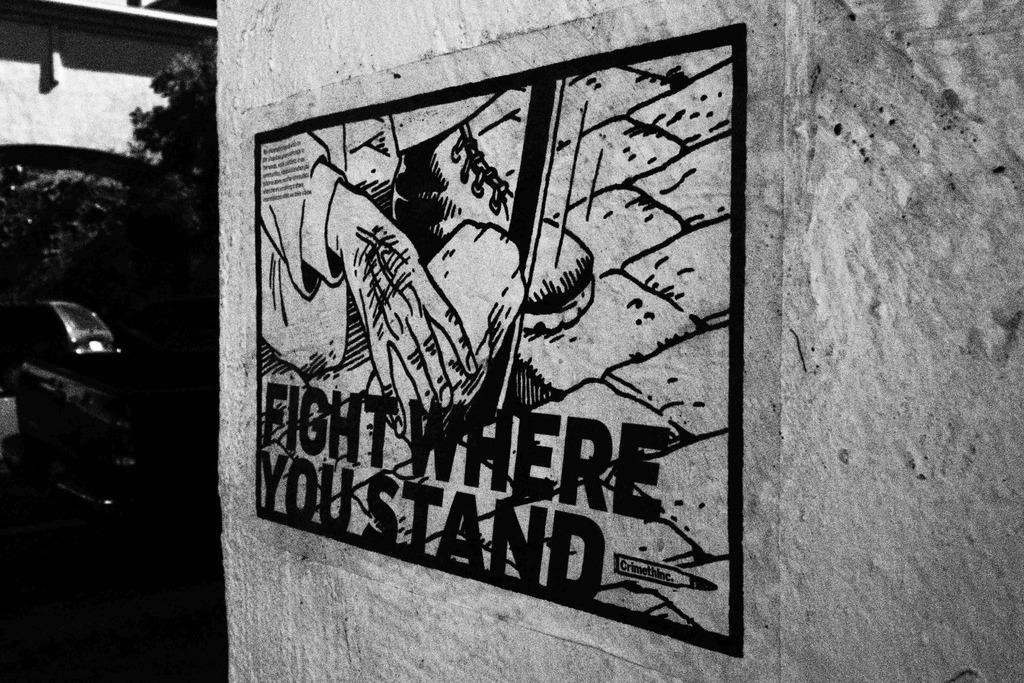Can you describe this image briefly? In this image we can see black and white picture of a painting with some text on the wall. in the background we can see a group of trees and building. 